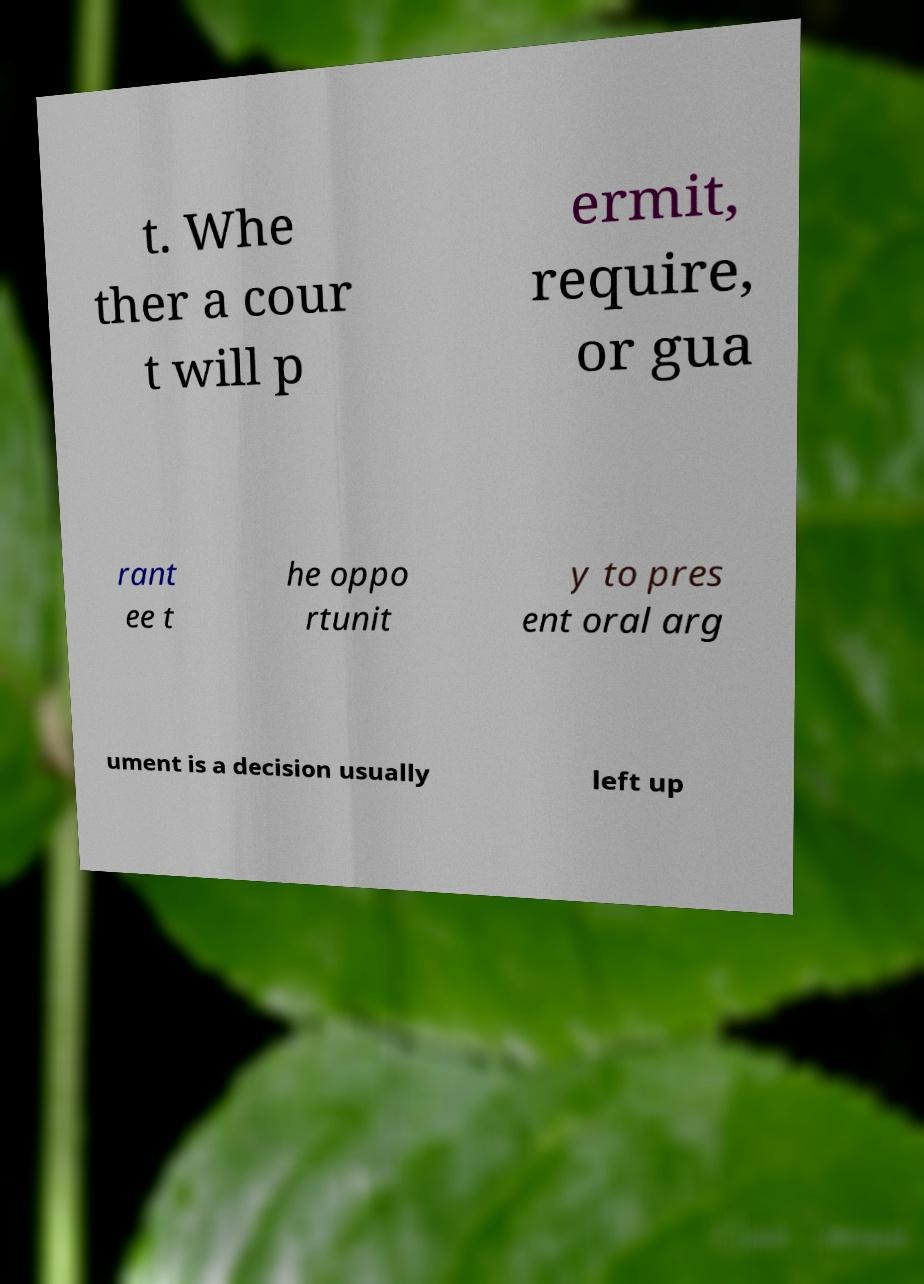Please identify and transcribe the text found in this image. t. Whe ther a cour t will p ermit, require, or gua rant ee t he oppo rtunit y to pres ent oral arg ument is a decision usually left up 